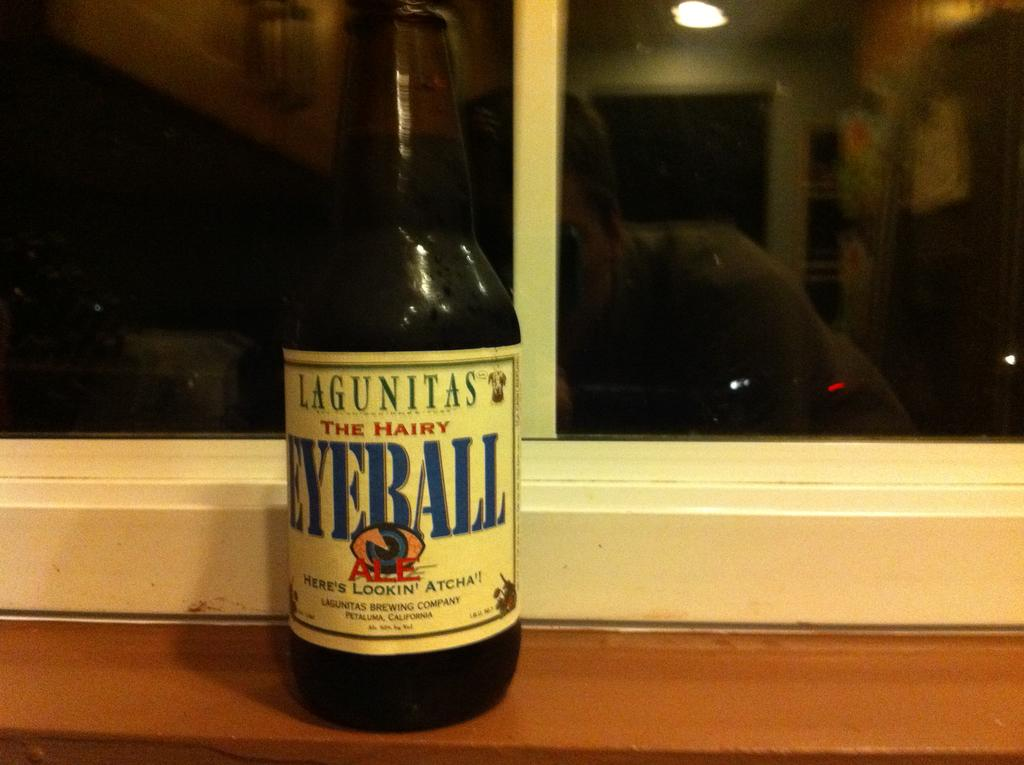<image>
Write a terse but informative summary of the picture. An Eyeball bottle placed by a window at night. 